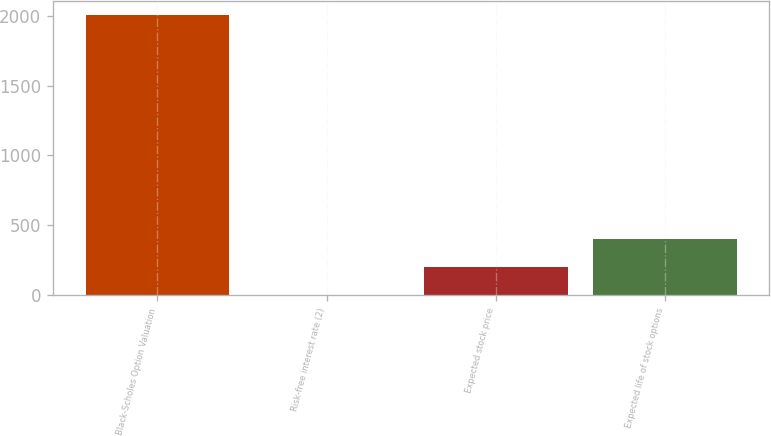Convert chart to OTSL. <chart><loc_0><loc_0><loc_500><loc_500><bar_chart><fcel>Black-Scholes Option Valuation<fcel>Risk-free interest rate (2)<fcel>Expected stock price<fcel>Expected life of stock options<nl><fcel>2005<fcel>3.7<fcel>203.83<fcel>403.96<nl></chart> 